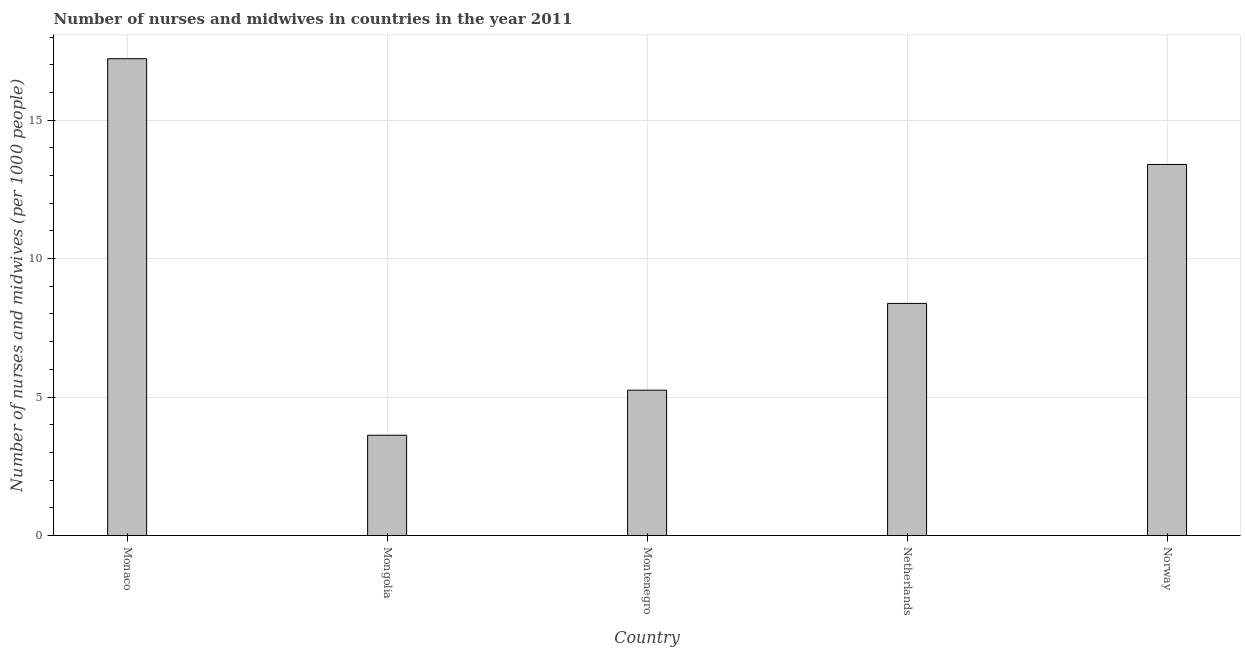What is the title of the graph?
Offer a very short reply. Number of nurses and midwives in countries in the year 2011. What is the label or title of the X-axis?
Your answer should be compact. Country. What is the label or title of the Y-axis?
Your answer should be very brief. Number of nurses and midwives (per 1000 people). What is the number of nurses and midwives in Netherlands?
Your response must be concise. 8.38. Across all countries, what is the maximum number of nurses and midwives?
Ensure brevity in your answer.  17.22. Across all countries, what is the minimum number of nurses and midwives?
Keep it short and to the point. 3.62. In which country was the number of nurses and midwives maximum?
Provide a succinct answer. Monaco. In which country was the number of nurses and midwives minimum?
Offer a terse response. Mongolia. What is the sum of the number of nurses and midwives?
Offer a very short reply. 47.87. What is the difference between the number of nurses and midwives in Montenegro and Norway?
Make the answer very short. -8.15. What is the average number of nurses and midwives per country?
Give a very brief answer. 9.57. What is the median number of nurses and midwives?
Offer a terse response. 8.38. In how many countries, is the number of nurses and midwives greater than 12 ?
Provide a succinct answer. 2. What is the ratio of the number of nurses and midwives in Netherlands to that in Norway?
Your answer should be very brief. 0.63. Is the difference between the number of nurses and midwives in Mongolia and Norway greater than the difference between any two countries?
Your answer should be compact. No. What is the difference between the highest and the second highest number of nurses and midwives?
Offer a terse response. 3.82. What is the difference between the highest and the lowest number of nurses and midwives?
Provide a succinct answer. 13.59. In how many countries, is the number of nurses and midwives greater than the average number of nurses and midwives taken over all countries?
Provide a short and direct response. 2. How many bars are there?
Ensure brevity in your answer.  5. Are all the bars in the graph horizontal?
Give a very brief answer. No. What is the difference between two consecutive major ticks on the Y-axis?
Provide a succinct answer. 5. What is the Number of nurses and midwives (per 1000 people) of Monaco?
Your answer should be very brief. 17.22. What is the Number of nurses and midwives (per 1000 people) of Mongolia?
Provide a succinct answer. 3.62. What is the Number of nurses and midwives (per 1000 people) in Montenegro?
Make the answer very short. 5.25. What is the Number of nurses and midwives (per 1000 people) of Netherlands?
Offer a terse response. 8.38. What is the Number of nurses and midwives (per 1000 people) of Norway?
Provide a short and direct response. 13.4. What is the difference between the Number of nurses and midwives (per 1000 people) in Monaco and Mongolia?
Provide a short and direct response. 13.6. What is the difference between the Number of nurses and midwives (per 1000 people) in Monaco and Montenegro?
Offer a very short reply. 11.97. What is the difference between the Number of nurses and midwives (per 1000 people) in Monaco and Netherlands?
Make the answer very short. 8.84. What is the difference between the Number of nurses and midwives (per 1000 people) in Monaco and Norway?
Your answer should be compact. 3.82. What is the difference between the Number of nurses and midwives (per 1000 people) in Mongolia and Montenegro?
Provide a succinct answer. -1.63. What is the difference between the Number of nurses and midwives (per 1000 people) in Mongolia and Netherlands?
Offer a terse response. -4.76. What is the difference between the Number of nurses and midwives (per 1000 people) in Mongolia and Norway?
Ensure brevity in your answer.  -9.78. What is the difference between the Number of nurses and midwives (per 1000 people) in Montenegro and Netherlands?
Give a very brief answer. -3.13. What is the difference between the Number of nurses and midwives (per 1000 people) in Montenegro and Norway?
Provide a short and direct response. -8.15. What is the difference between the Number of nurses and midwives (per 1000 people) in Netherlands and Norway?
Your answer should be very brief. -5.02. What is the ratio of the Number of nurses and midwives (per 1000 people) in Monaco to that in Mongolia?
Your response must be concise. 4.75. What is the ratio of the Number of nurses and midwives (per 1000 people) in Monaco to that in Montenegro?
Offer a terse response. 3.28. What is the ratio of the Number of nurses and midwives (per 1000 people) in Monaco to that in Netherlands?
Keep it short and to the point. 2.05. What is the ratio of the Number of nurses and midwives (per 1000 people) in Monaco to that in Norway?
Make the answer very short. 1.28. What is the ratio of the Number of nurses and midwives (per 1000 people) in Mongolia to that in Montenegro?
Your answer should be compact. 0.69. What is the ratio of the Number of nurses and midwives (per 1000 people) in Mongolia to that in Netherlands?
Make the answer very short. 0.43. What is the ratio of the Number of nurses and midwives (per 1000 people) in Mongolia to that in Norway?
Provide a succinct answer. 0.27. What is the ratio of the Number of nurses and midwives (per 1000 people) in Montenegro to that in Netherlands?
Your answer should be very brief. 0.63. What is the ratio of the Number of nurses and midwives (per 1000 people) in Montenegro to that in Norway?
Your response must be concise. 0.39. What is the ratio of the Number of nurses and midwives (per 1000 people) in Netherlands to that in Norway?
Keep it short and to the point. 0.63. 